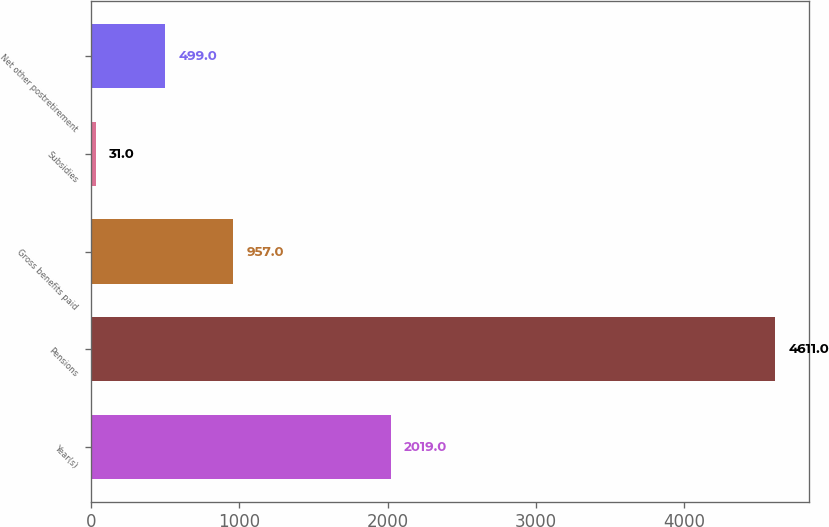Convert chart to OTSL. <chart><loc_0><loc_0><loc_500><loc_500><bar_chart><fcel>Year(s)<fcel>Pensions<fcel>Gross benefits paid<fcel>Subsidies<fcel>Net other postretirement<nl><fcel>2019<fcel>4611<fcel>957<fcel>31<fcel>499<nl></chart> 